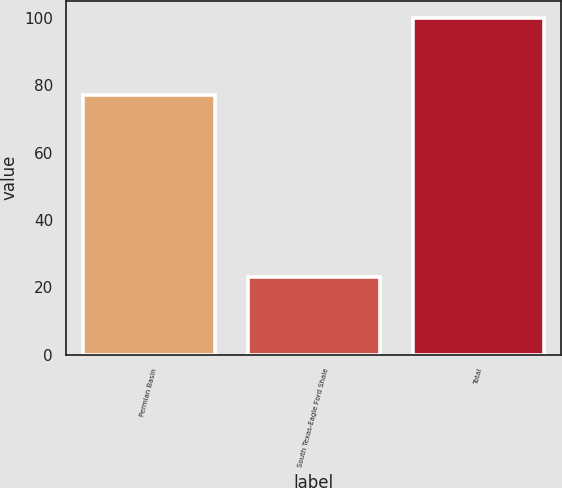Convert chart. <chart><loc_0><loc_0><loc_500><loc_500><bar_chart><fcel>Permian Basin<fcel>South Texas-Eagle Ford Shale<fcel>Total<nl><fcel>77<fcel>23<fcel>100<nl></chart> 